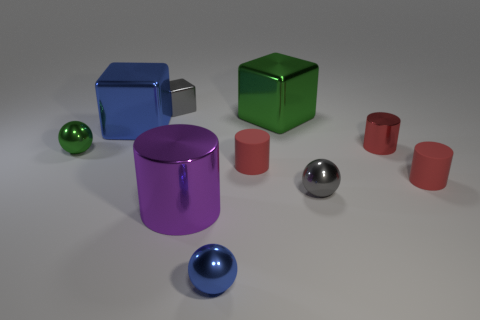How many purple metallic objects are the same size as the green metal sphere?
Your answer should be compact. 0. Is the shape of the big purple object the same as the small red metallic object?
Give a very brief answer. Yes. What color is the small ball right of the large cube behind the big blue metal thing?
Provide a succinct answer. Gray. How big is the object that is both behind the large blue cube and right of the purple object?
Give a very brief answer. Large. Is there any other thing of the same color as the large metal cylinder?
Offer a terse response. No. There is a big green thing that is made of the same material as the big purple thing; what shape is it?
Offer a terse response. Cube. Is the shape of the small red metallic object the same as the big thing that is in front of the tiny green ball?
Your answer should be compact. Yes. What material is the tiny blue thing right of the small shiny block that is left of the gray ball?
Provide a succinct answer. Metal. Are there the same number of metal balls that are in front of the small green object and metal cylinders?
Your answer should be compact. Yes. Is the color of the tiny metal sphere that is behind the small gray metal sphere the same as the large metal cube on the right side of the purple metallic cylinder?
Provide a short and direct response. Yes. 